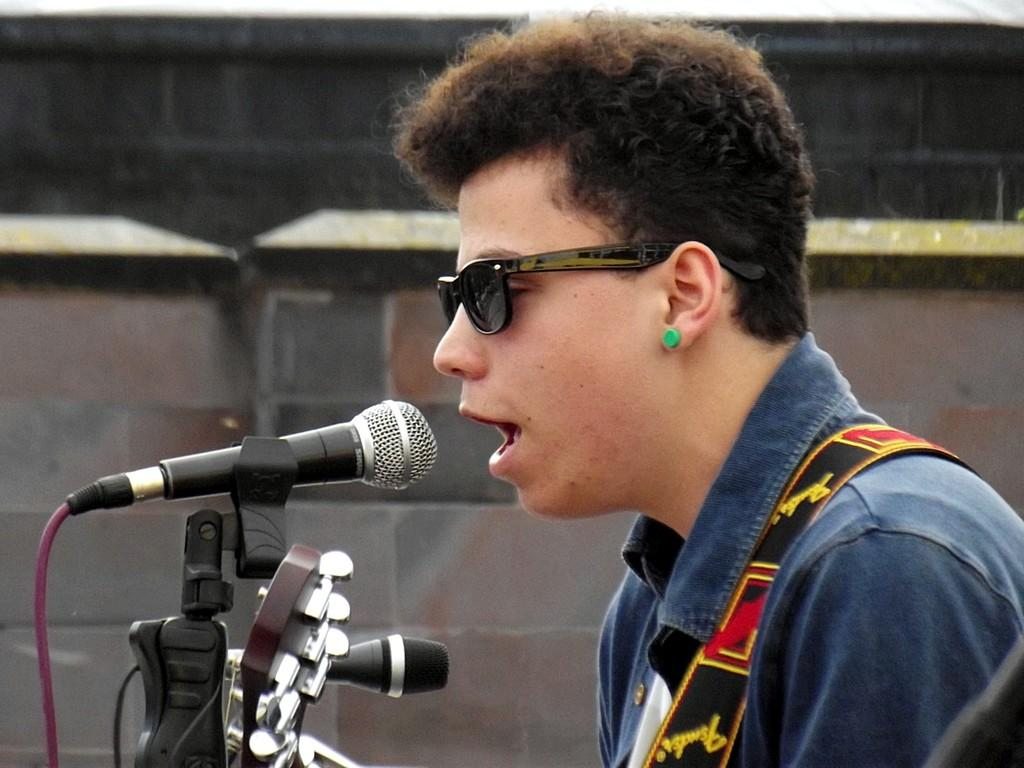Who or what is the main subject in the image? There is a person in the image. What objects are in front of the person? There are microphones in front of the person. What can be seen behind the person? There is a wall behind the person. What type of butter is being used by the person in the image? There is no butter present in the image. What color are the jeans worn by the person in the image? The provided facts do not mention the person's clothing, so we cannot determine the color of their jeans. 